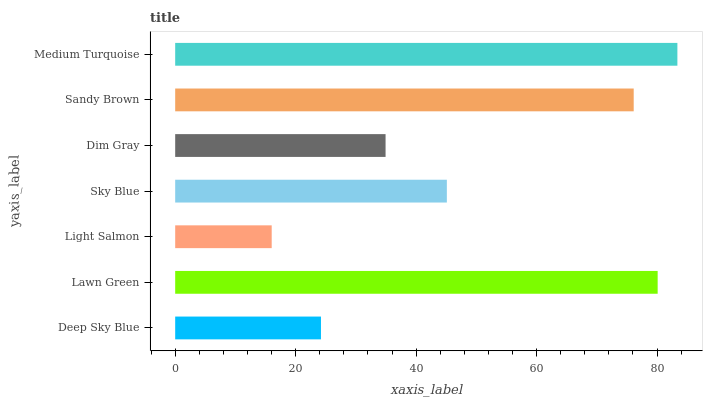Is Light Salmon the minimum?
Answer yes or no. Yes. Is Medium Turquoise the maximum?
Answer yes or no. Yes. Is Lawn Green the minimum?
Answer yes or no. No. Is Lawn Green the maximum?
Answer yes or no. No. Is Lawn Green greater than Deep Sky Blue?
Answer yes or no. Yes. Is Deep Sky Blue less than Lawn Green?
Answer yes or no. Yes. Is Deep Sky Blue greater than Lawn Green?
Answer yes or no. No. Is Lawn Green less than Deep Sky Blue?
Answer yes or no. No. Is Sky Blue the high median?
Answer yes or no. Yes. Is Sky Blue the low median?
Answer yes or no. Yes. Is Medium Turquoise the high median?
Answer yes or no. No. Is Medium Turquoise the low median?
Answer yes or no. No. 